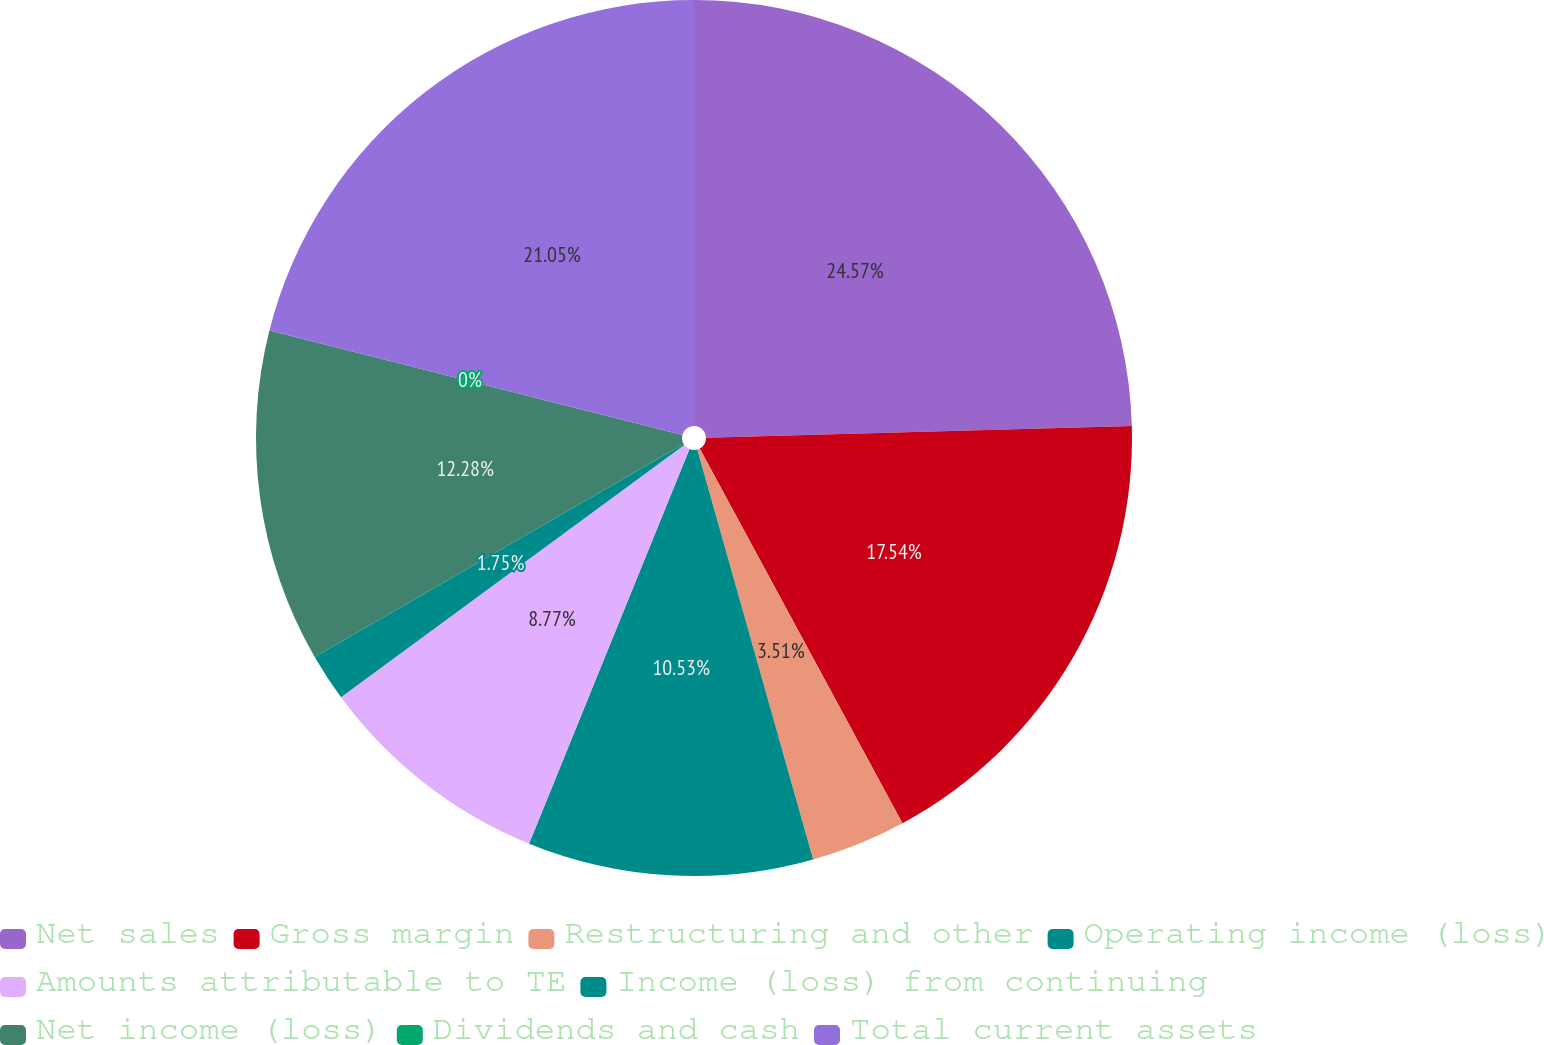Convert chart to OTSL. <chart><loc_0><loc_0><loc_500><loc_500><pie_chart><fcel>Net sales<fcel>Gross margin<fcel>Restructuring and other<fcel>Operating income (loss)<fcel>Amounts attributable to TE<fcel>Income (loss) from continuing<fcel>Net income (loss)<fcel>Dividends and cash<fcel>Total current assets<nl><fcel>24.56%<fcel>17.54%<fcel>3.51%<fcel>10.53%<fcel>8.77%<fcel>1.75%<fcel>12.28%<fcel>0.0%<fcel>21.05%<nl></chart> 